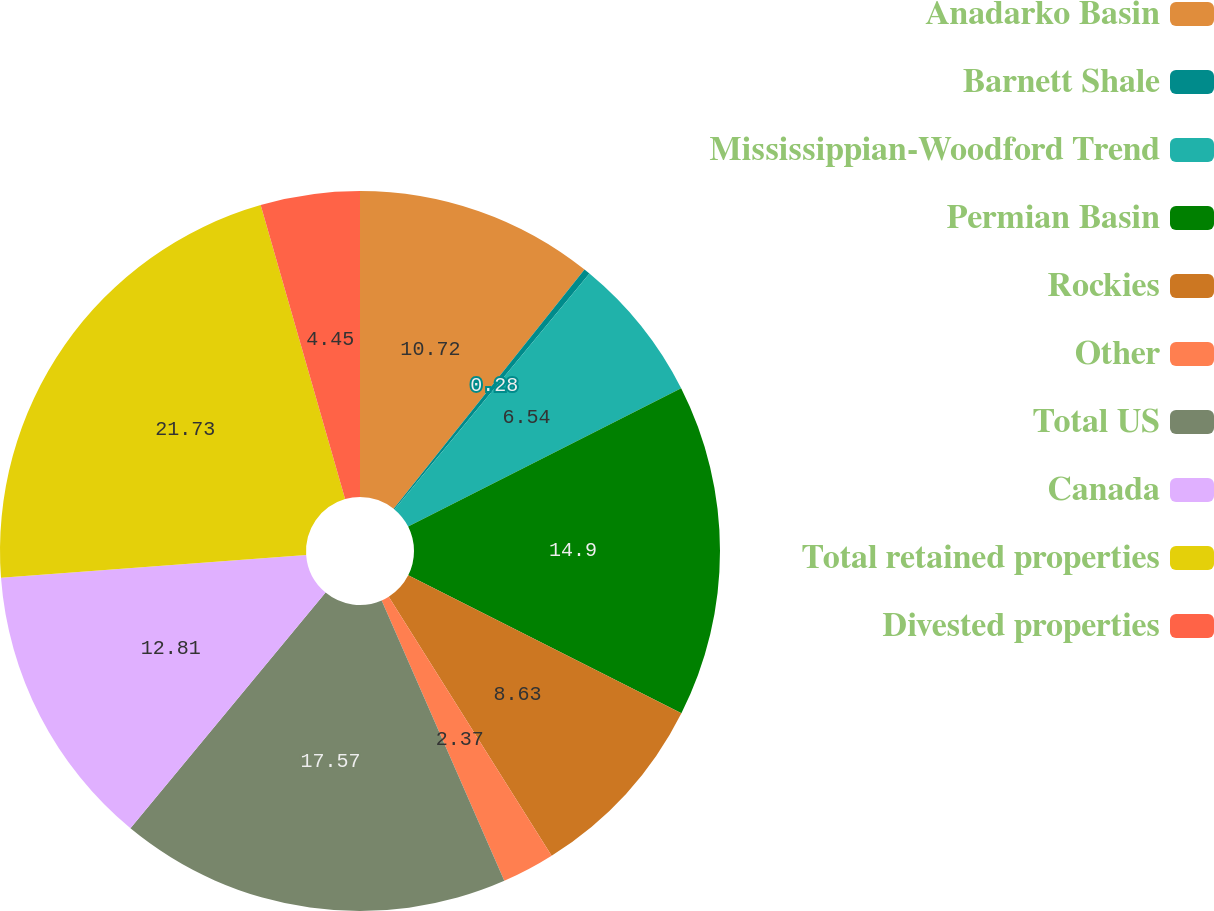Convert chart to OTSL. <chart><loc_0><loc_0><loc_500><loc_500><pie_chart><fcel>Anadarko Basin<fcel>Barnett Shale<fcel>Mississippian-Woodford Trend<fcel>Permian Basin<fcel>Rockies<fcel>Other<fcel>Total US<fcel>Canada<fcel>Total retained properties<fcel>Divested properties<nl><fcel>10.72%<fcel>0.28%<fcel>6.54%<fcel>14.9%<fcel>8.63%<fcel>2.37%<fcel>17.57%<fcel>12.81%<fcel>21.74%<fcel>4.45%<nl></chart> 